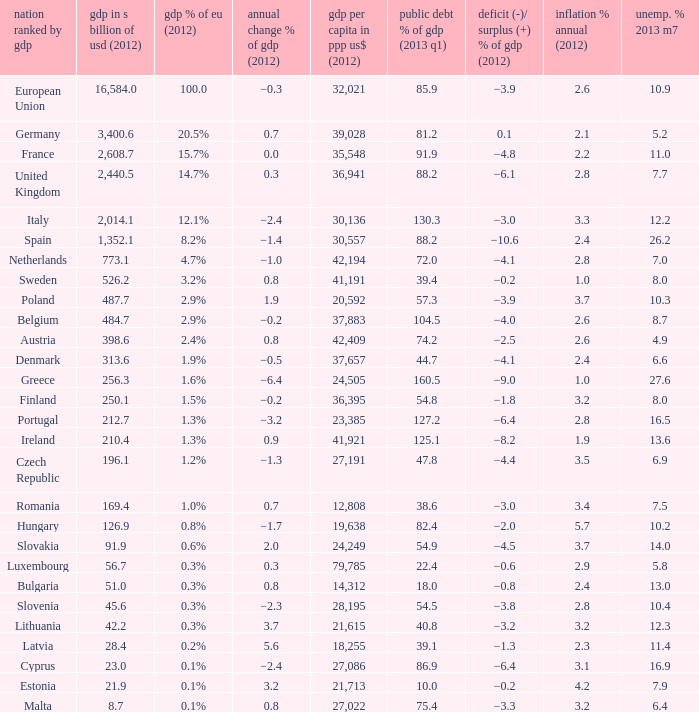What is the largest inflation % annual in 2012 of the country with a public debt % of GDP in 2013 Q1 greater than 88.2 and a GDP % of EU in 2012 of 2.9%? 2.6. 